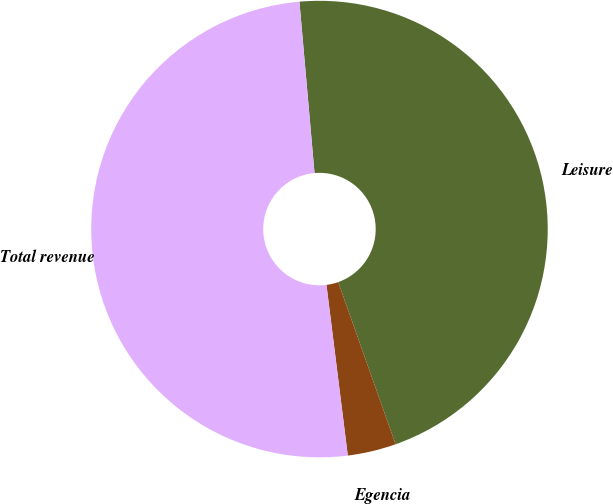Convert chart. <chart><loc_0><loc_0><loc_500><loc_500><pie_chart><fcel>Leisure<fcel>Egencia<fcel>Total revenue<nl><fcel>45.99%<fcel>3.43%<fcel>50.58%<nl></chart> 